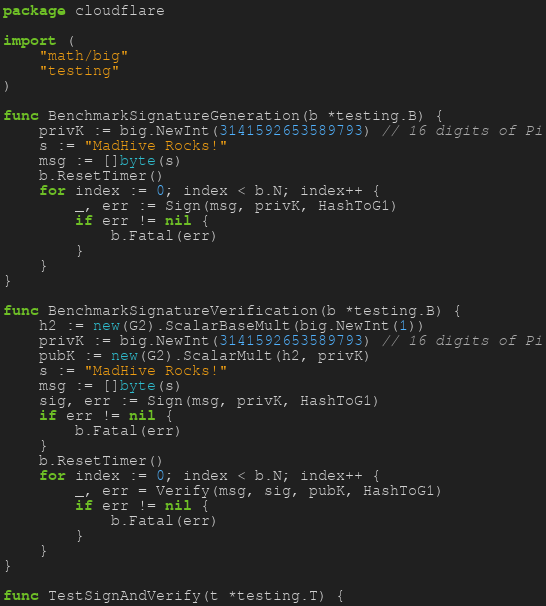Convert code to text. <code><loc_0><loc_0><loc_500><loc_500><_Go_>package cloudflare

import (
	"math/big"
	"testing"
)

func BenchmarkSignatureGeneration(b *testing.B) {
	privK := big.NewInt(3141592653589793) // 16 digits of Pi
	s := "MadHive Rocks!"
	msg := []byte(s)
	b.ResetTimer()
	for index := 0; index < b.N; index++ {
		_, err := Sign(msg, privK, HashToG1)
		if err != nil {
			b.Fatal(err)
		}
	}
}

func BenchmarkSignatureVerification(b *testing.B) {
	h2 := new(G2).ScalarBaseMult(big.NewInt(1))
	privK := big.NewInt(3141592653589793) // 16 digits of Pi
	pubK := new(G2).ScalarMult(h2, privK)
	s := "MadHive Rocks!"
	msg := []byte(s)
	sig, err := Sign(msg, privK, HashToG1)
	if err != nil {
		b.Fatal(err)
	}
	b.ResetTimer()
	for index := 0; index < b.N; index++ {
		_, err = Verify(msg, sig, pubK, HashToG1)
		if err != nil {
			b.Fatal(err)
		}
	}
}

func TestSignAndVerify(t *testing.T) {</code> 